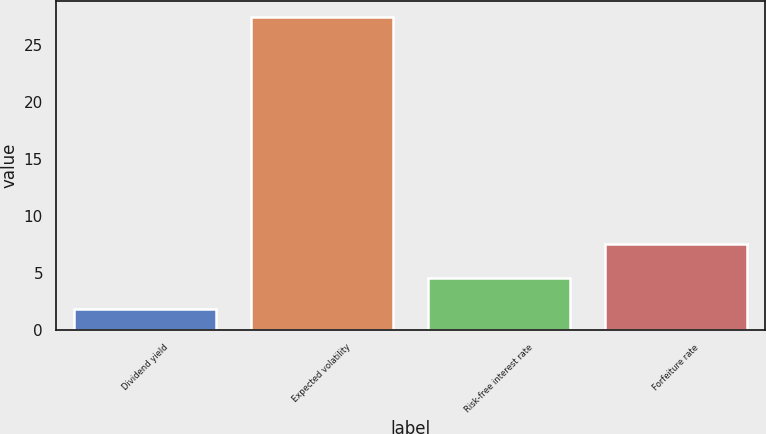Convert chart. <chart><loc_0><loc_0><loc_500><loc_500><bar_chart><fcel>Dividend yield<fcel>Expected volatility<fcel>Risk-free interest rate<fcel>Forfeiture rate<nl><fcel>1.78<fcel>27.43<fcel>4.51<fcel>7.5<nl></chart> 